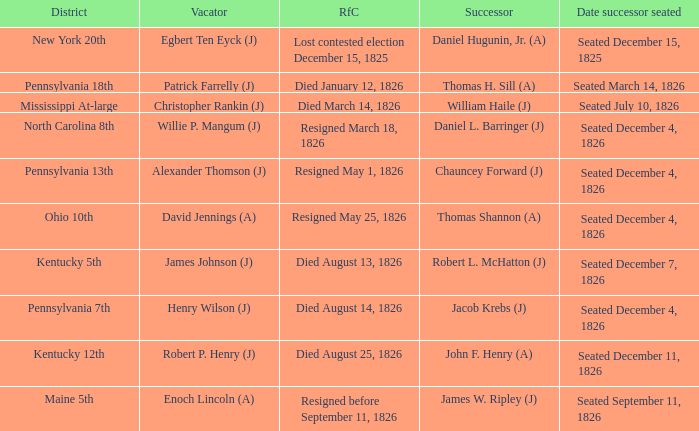Name the reason for change pennsylvania 13th Resigned May 1, 1826. 